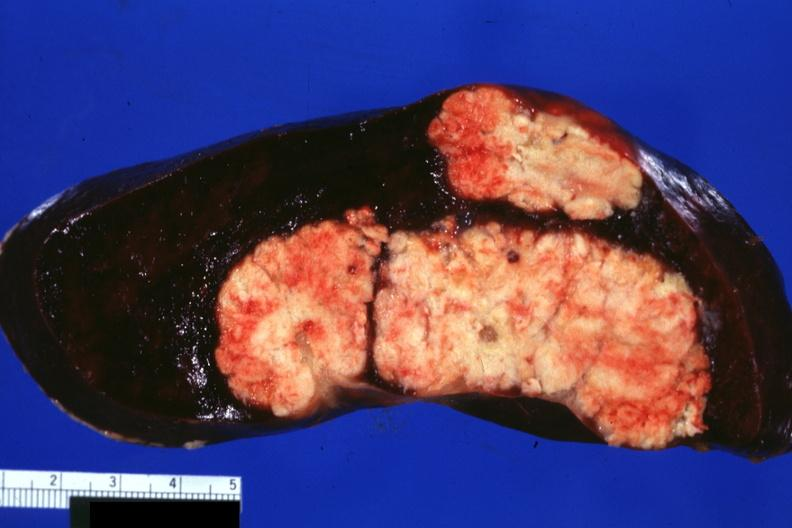what very well shown?
Answer the question using a single word or phrase. Large and typical metastatic lesions in spleen 